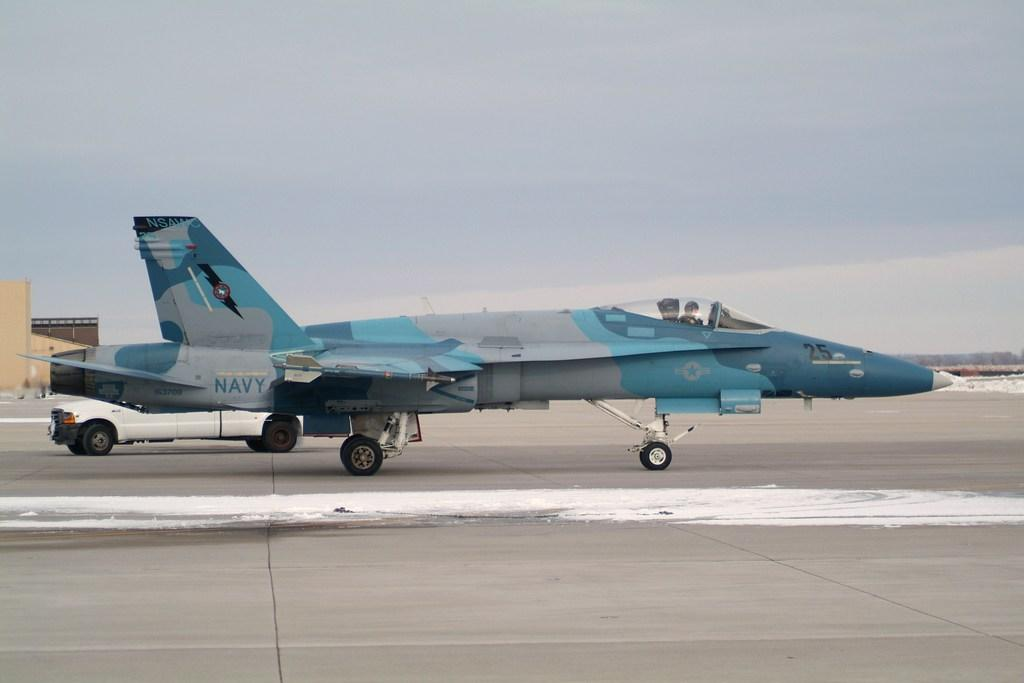What is the main subject of the picture? The main subject of the picture is an aircraft. What else can be seen in the picture besides the aircraft? There is a vehicle, a road, buildings, and the sky visible in the picture. What is the condition of the sky in the picture? The sky is visible in the picture, and clouds are present. How many dinosaurs can be seen walking on the road in the image? There are no dinosaurs present in the image; it features an aircraft, a vehicle, a road, buildings, and a sky with clouds. What type of spark can be seen coming from the aircraft in the image? There is no spark visible coming from the aircraft in the image. 